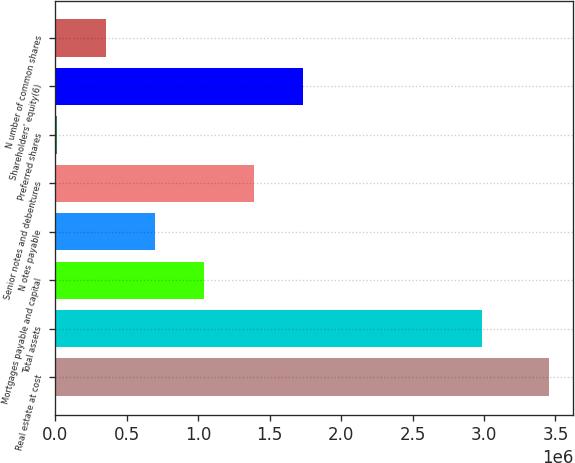<chart> <loc_0><loc_0><loc_500><loc_500><bar_chart><fcel>Real estate at cost<fcel>Total assets<fcel>Mortgages payable and capital<fcel>N otes payable<fcel>Senior notes and debentures<fcel>Preferred shares<fcel>Shareholders' equity(6)<fcel>N umber of common shares<nl><fcel>3.45285e+06<fcel>2.9893e+06<fcel>1.04285e+06<fcel>698567<fcel>1.38714e+06<fcel>9997<fcel>1.73142e+06<fcel>354282<nl></chart> 